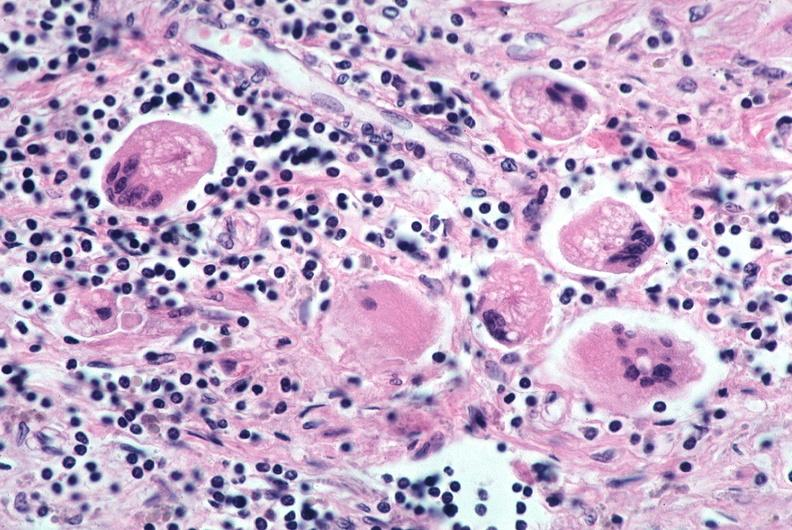what does this image show?
Answer the question using a single word or phrase. Lung 